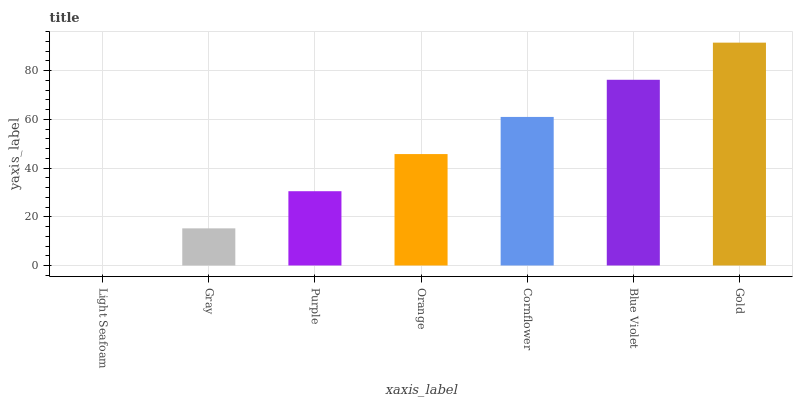Is Light Seafoam the minimum?
Answer yes or no. Yes. Is Gold the maximum?
Answer yes or no. Yes. Is Gray the minimum?
Answer yes or no. No. Is Gray the maximum?
Answer yes or no. No. Is Gray greater than Light Seafoam?
Answer yes or no. Yes. Is Light Seafoam less than Gray?
Answer yes or no. Yes. Is Light Seafoam greater than Gray?
Answer yes or no. No. Is Gray less than Light Seafoam?
Answer yes or no. No. Is Orange the high median?
Answer yes or no. Yes. Is Orange the low median?
Answer yes or no. Yes. Is Light Seafoam the high median?
Answer yes or no. No. Is Gold the low median?
Answer yes or no. No. 